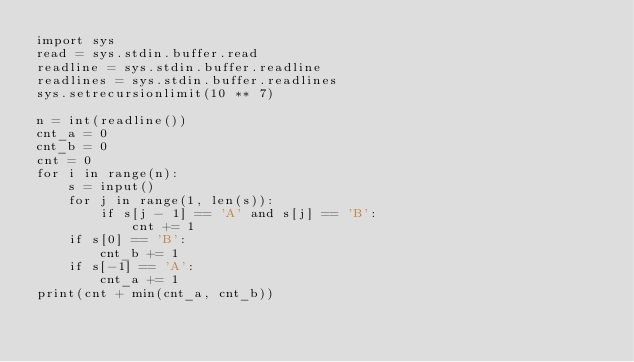Convert code to text. <code><loc_0><loc_0><loc_500><loc_500><_Python_>import sys
read = sys.stdin.buffer.read
readline = sys.stdin.buffer.readline
readlines = sys.stdin.buffer.readlines
sys.setrecursionlimit(10 ** 7)

n = int(readline())
cnt_a = 0
cnt_b = 0
cnt = 0
for i in range(n):
    s = input()
    for j in range(1, len(s)):
        if s[j - 1] == 'A' and s[j] == 'B':
            cnt += 1
    if s[0] == 'B':
        cnt_b += 1
    if s[-1] == 'A':
        cnt_a += 1
print(cnt + min(cnt_a, cnt_b))

</code> 